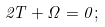<formula> <loc_0><loc_0><loc_500><loc_500>2 T + \Omega = 0 ;</formula> 